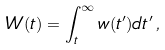Convert formula to latex. <formula><loc_0><loc_0><loc_500><loc_500>W ( t ) = \int _ { t } ^ { \infty } w ( t ^ { \prime } ) d t ^ { \prime } \, ,</formula> 